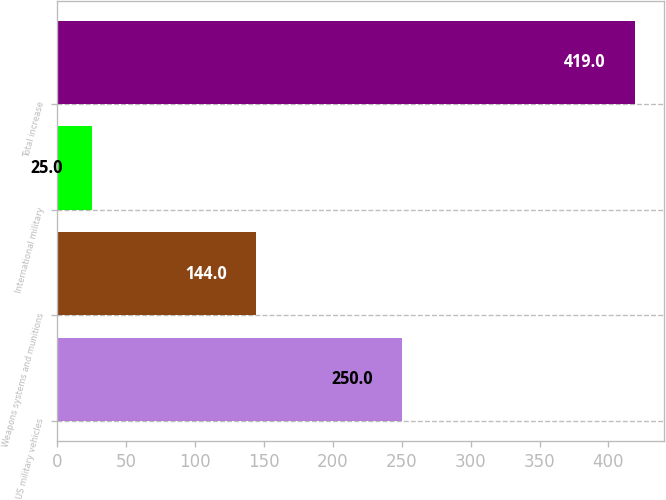Convert chart to OTSL. <chart><loc_0><loc_0><loc_500><loc_500><bar_chart><fcel>US military vehicles<fcel>Weapons systems and munitions<fcel>International military<fcel>Total increase<nl><fcel>250<fcel>144<fcel>25<fcel>419<nl></chart> 